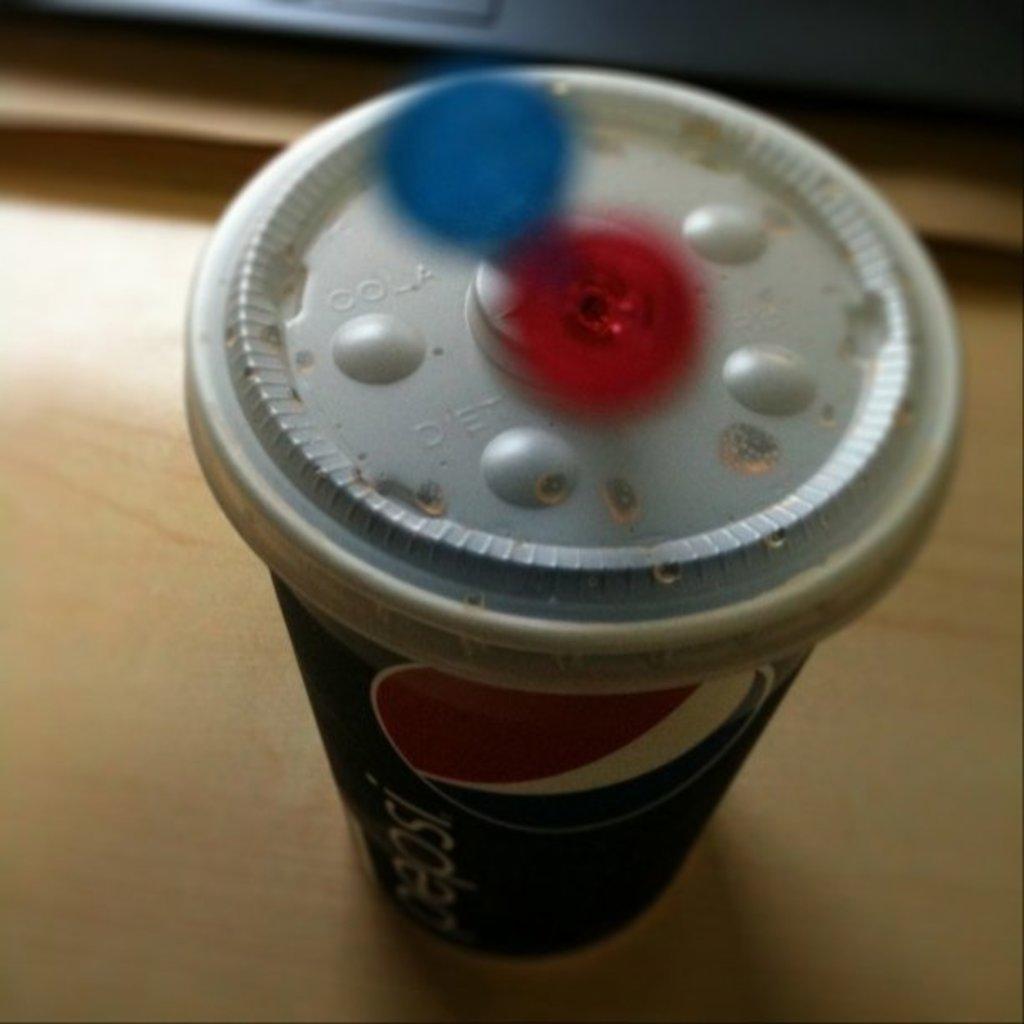What is written above the push circle on the top left of the lid?
Your response must be concise. Cola. 